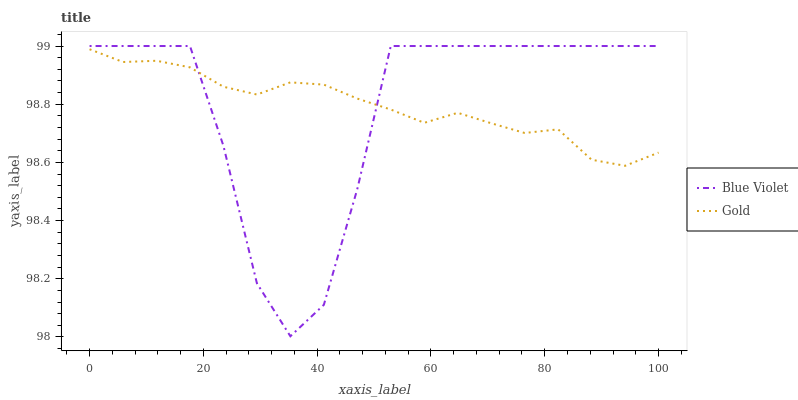Does Blue Violet have the minimum area under the curve?
Answer yes or no. Yes. Does Gold have the maximum area under the curve?
Answer yes or no. Yes. Does Blue Violet have the maximum area under the curve?
Answer yes or no. No. Is Gold the smoothest?
Answer yes or no. Yes. Is Blue Violet the roughest?
Answer yes or no. Yes. Is Blue Violet the smoothest?
Answer yes or no. No. Does Blue Violet have the lowest value?
Answer yes or no. Yes. Does Blue Violet have the highest value?
Answer yes or no. Yes. Does Blue Violet intersect Gold?
Answer yes or no. Yes. Is Blue Violet less than Gold?
Answer yes or no. No. Is Blue Violet greater than Gold?
Answer yes or no. No. 